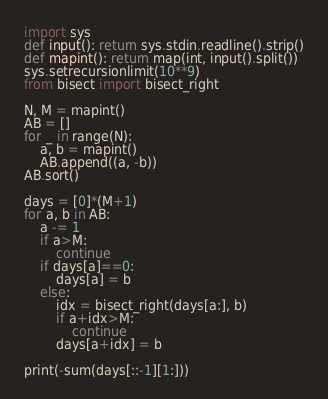<code> <loc_0><loc_0><loc_500><loc_500><_Python_>import sys
def input(): return sys.stdin.readline().strip()
def mapint(): return map(int, input().split())
sys.setrecursionlimit(10**9)
from bisect import bisect_right

N, M = mapint()
AB = []
for _ in range(N):
    a, b = mapint()
    AB.append((a, -b))
AB.sort()

days = [0]*(M+1)
for a, b in AB:
    a -= 1
    if a>M:
        continue
    if days[a]==0:
        days[a] = b
    else:
        idx = bisect_right(days[a:], b)
        if a+idx>M:
            continue
        days[a+idx] = b

print(-sum(days[::-1][1:]))</code> 